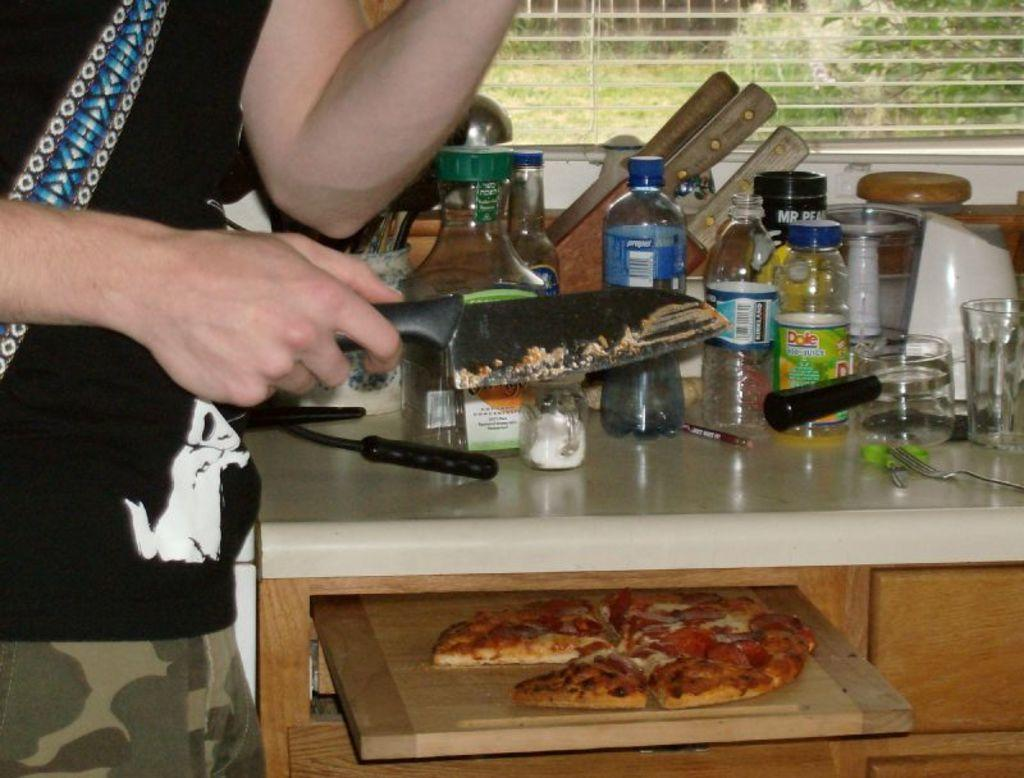<image>
Describe the image concisely. Person cutting pizza on a board beneath a counter that has a bottle marked Dole. 